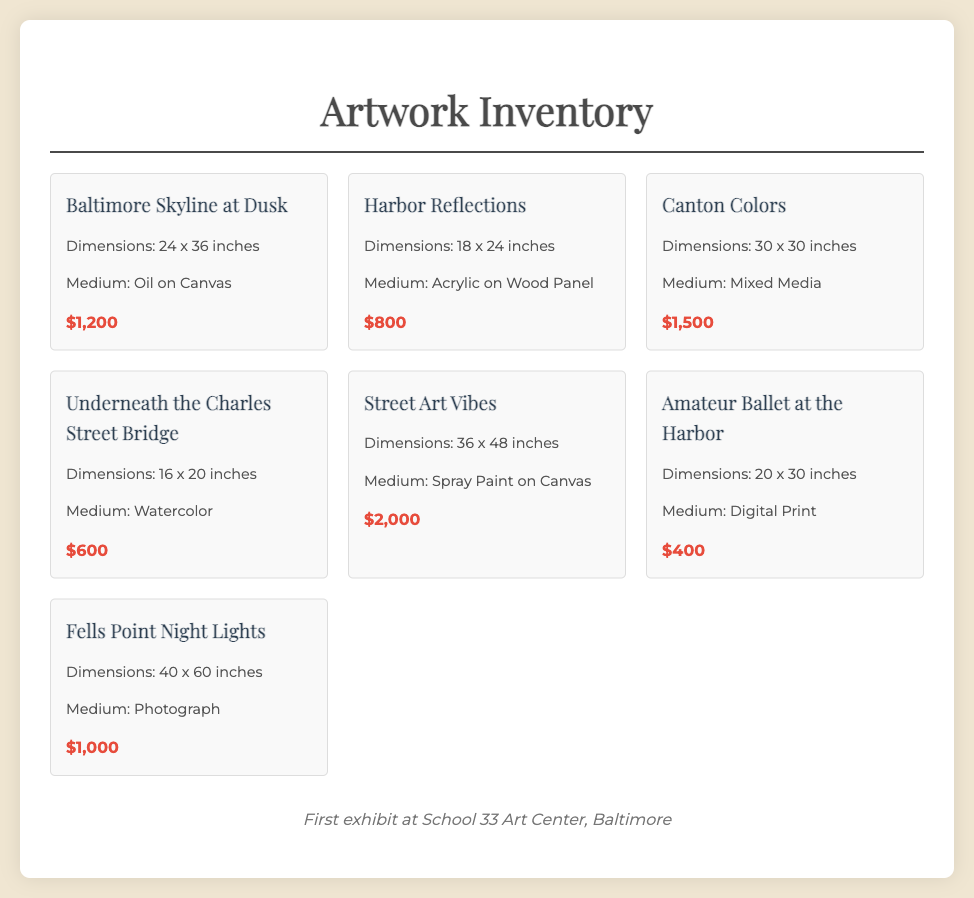What is the title of the largest artwork? The largest artwork can be determined by its dimensions, which is "36 x 48 inches". The title with these dimensions is "Street Art Vibes".
Answer: Street Art Vibes How much is "Canton Colors"? The price of "Canton Colors" is shown in the document as a specific amount.
Answer: $1,500 What medium is used for "Underneath the Charles Street Bridge"? The medium can be retrieved directly from the document for this specific title.
Answer: Watercolor What are the dimensions of "Baltimore Skyline at Dusk"? The dimensions are listed specifically under the title, making it easy to retrieve.
Answer: 24 x 36 inches Which artwork has a price of $400? This requires looking for the specific title associated with the given price.
Answer: Amateur Ballet at the Harbor How many artworks are displayed in total? The total number can be counted from the document by looking at the individual artwork entries.
Answer: 7 What is the medium of the "Fells Point Night Lights"? The medium is given under the title in the document and can be retrieved easily.
Answer: Photograph What is the price range of the artworks? This involves determining the minimum and maximum prices from the provided artworks. The range is clearly stated through the listed prices.
Answer: $400 - $2,000 What event is mentioned in the footer? The footer contains information about the artist's first exhibit, which is specifically stated.
Answer: School 33 Art Center, Baltimore 